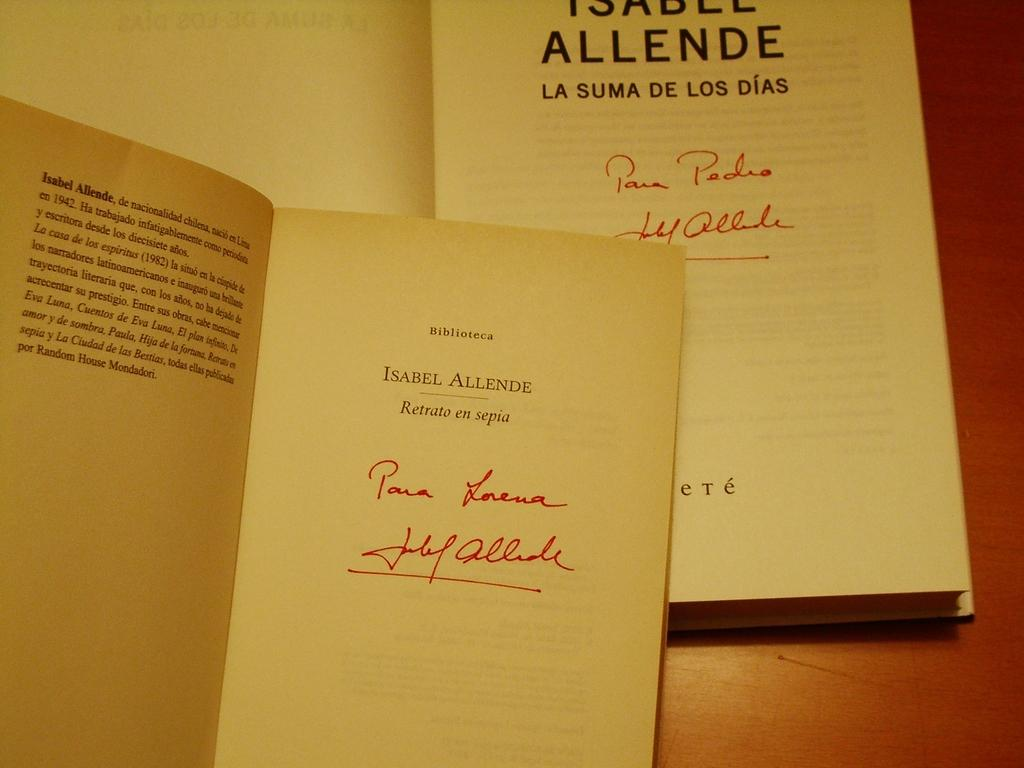Provide a one-sentence caption for the provided image. Book and booklet that includes Isabel Allende information. 